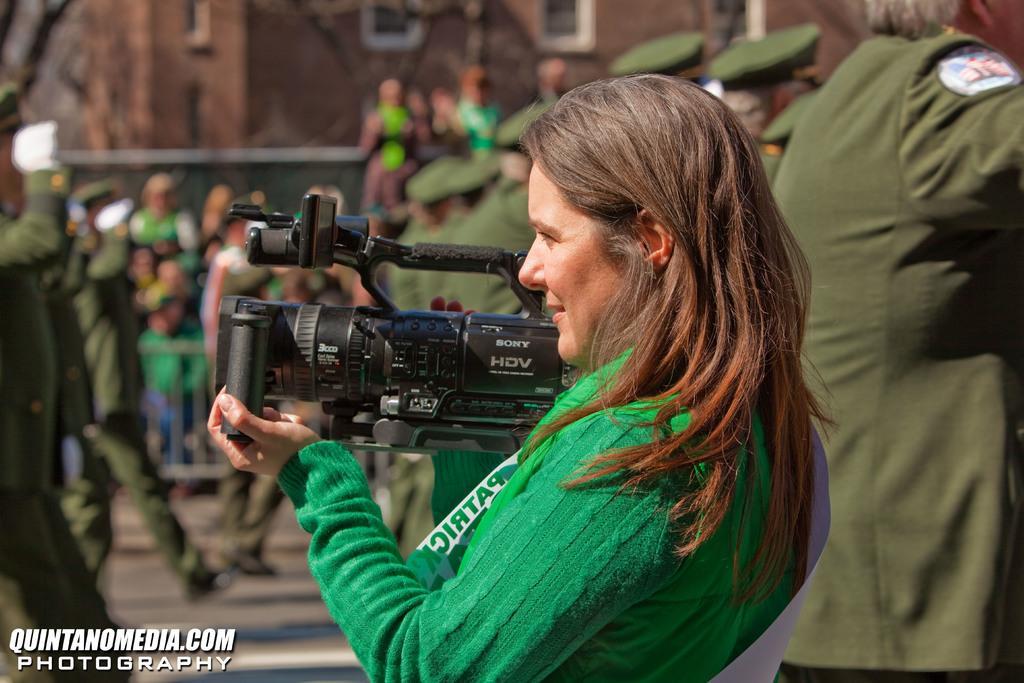Could you give a brief overview of what you see in this image? In this image I see a man who is holding a camera and there are lot of people, a building in the background. 